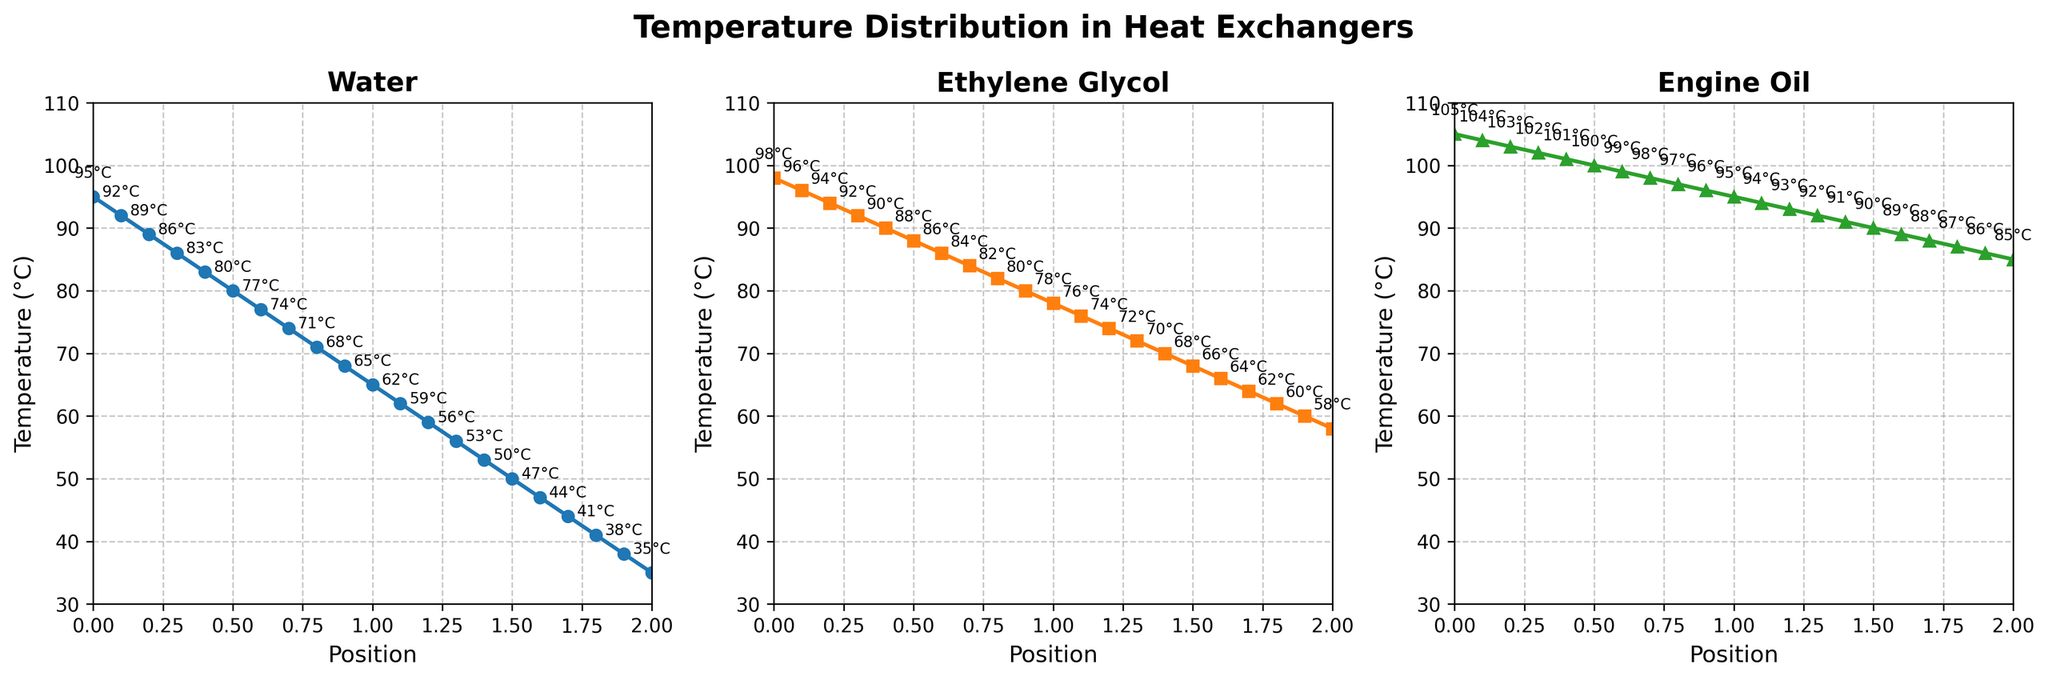What coolant shows the highest temperature at a position of 0.8? The plot shows temperature distributions for three coolants at various positions. At position 0.8, Engine Oil has the highest temperature.
Answer: Engine Oil Which coolant has the steepest decline in temperature from position 0 to 2? To determine the steepest decline, compare the difference in temperature from position 0 to 2 for each coolant. Ethylene Glycol drops from 98°C to 58°C (40°C difference), which is the steepest.
Answer: Ethylene Glycol What is the average temperature of Water at positions 1 and 1.5? Find the temperatures of Water at positions 1 and 1.5, which are 65°C and 50°C respectively. The average is (65 + 50) / 2 = 57.5°C.
Answer: 57.5°C Which coolant maintains the highest temperature throughout the positions? From the plot, Engine Oil consistently has higher temperatures compared to Water and Ethylene Glycol across all positions.
Answer: Engine Oil At what position does Ethylene Glycol cross below 80°C? Follow the plot line for Ethylene Glycol and identify where the temperature first drops below 80°C. This occurs between positions 0.9 and 1.0, precisely at position 1.
Answer: 1.0 How does the temperature gradient of Water compare to that of Engine Oil? Comparing the slopes of the lines, Water decreases more rapidly (steeper slope) per position than Engine Oil, indicating that Water has a higher temperature gradient.
Answer: Water's gradient is steeper Which coolant shows the least variation in temperature from position 0 to 2? Calculate the temperature difference for each coolant from position 0 to 2. Engine Oil has a difference of 20°C (105°C to 85°C), which is the least variation.
Answer: Engine Oil Explain why Engine Oil is a better coolant than Water based on the given plot. Engine Oil maintains higher temperatures throughout the positions, indicating better heat absorption and dissipation properties compared to Water, which drops more rapidly.
Answer: Better heat absorption and dissipation 